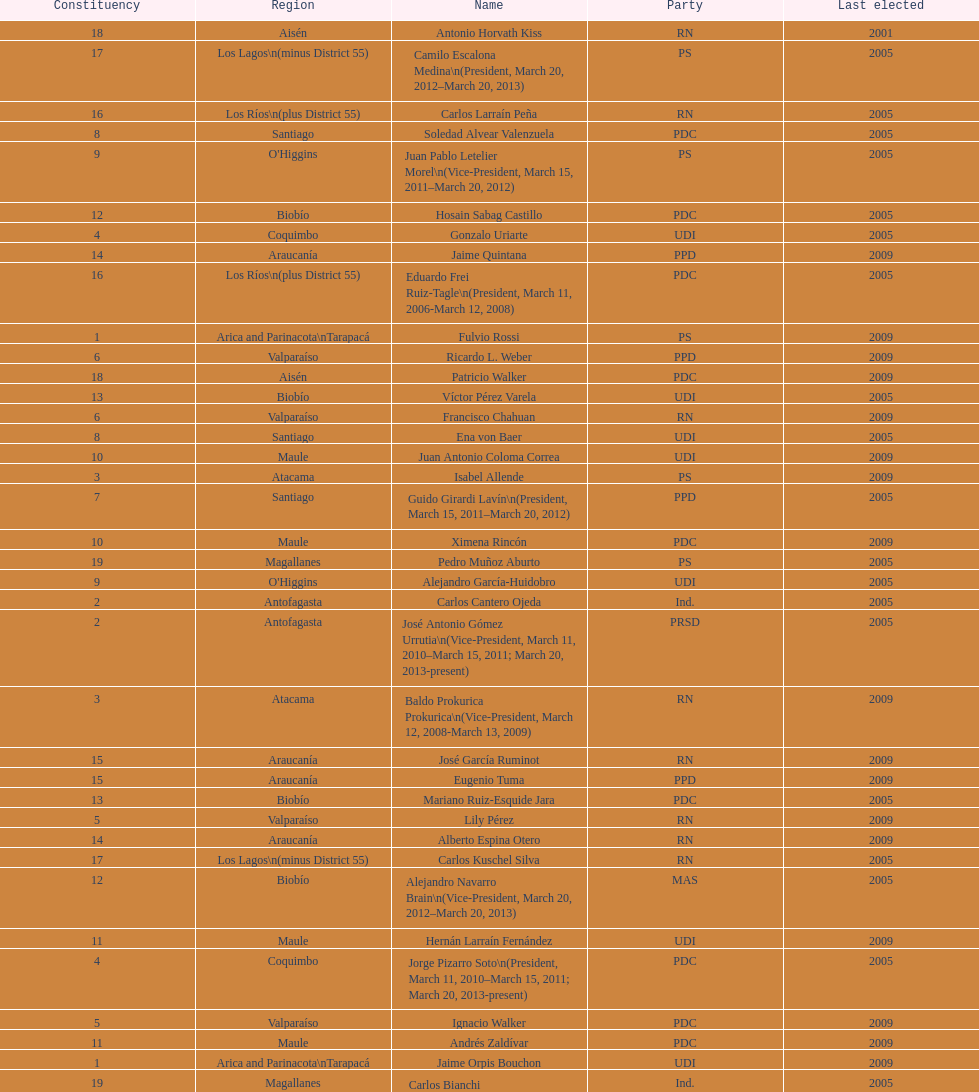What is the last region listed on the table? Magallanes. 